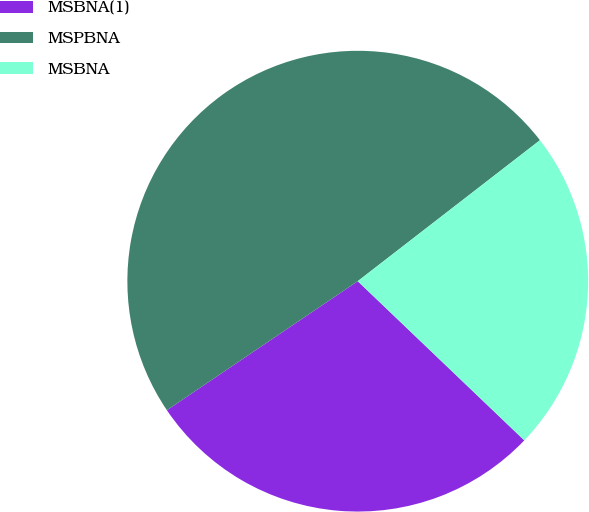<chart> <loc_0><loc_0><loc_500><loc_500><pie_chart><fcel>MSBNA(1)<fcel>MSPBNA<fcel>MSBNA<nl><fcel>28.4%<fcel>48.98%<fcel>22.62%<nl></chart> 